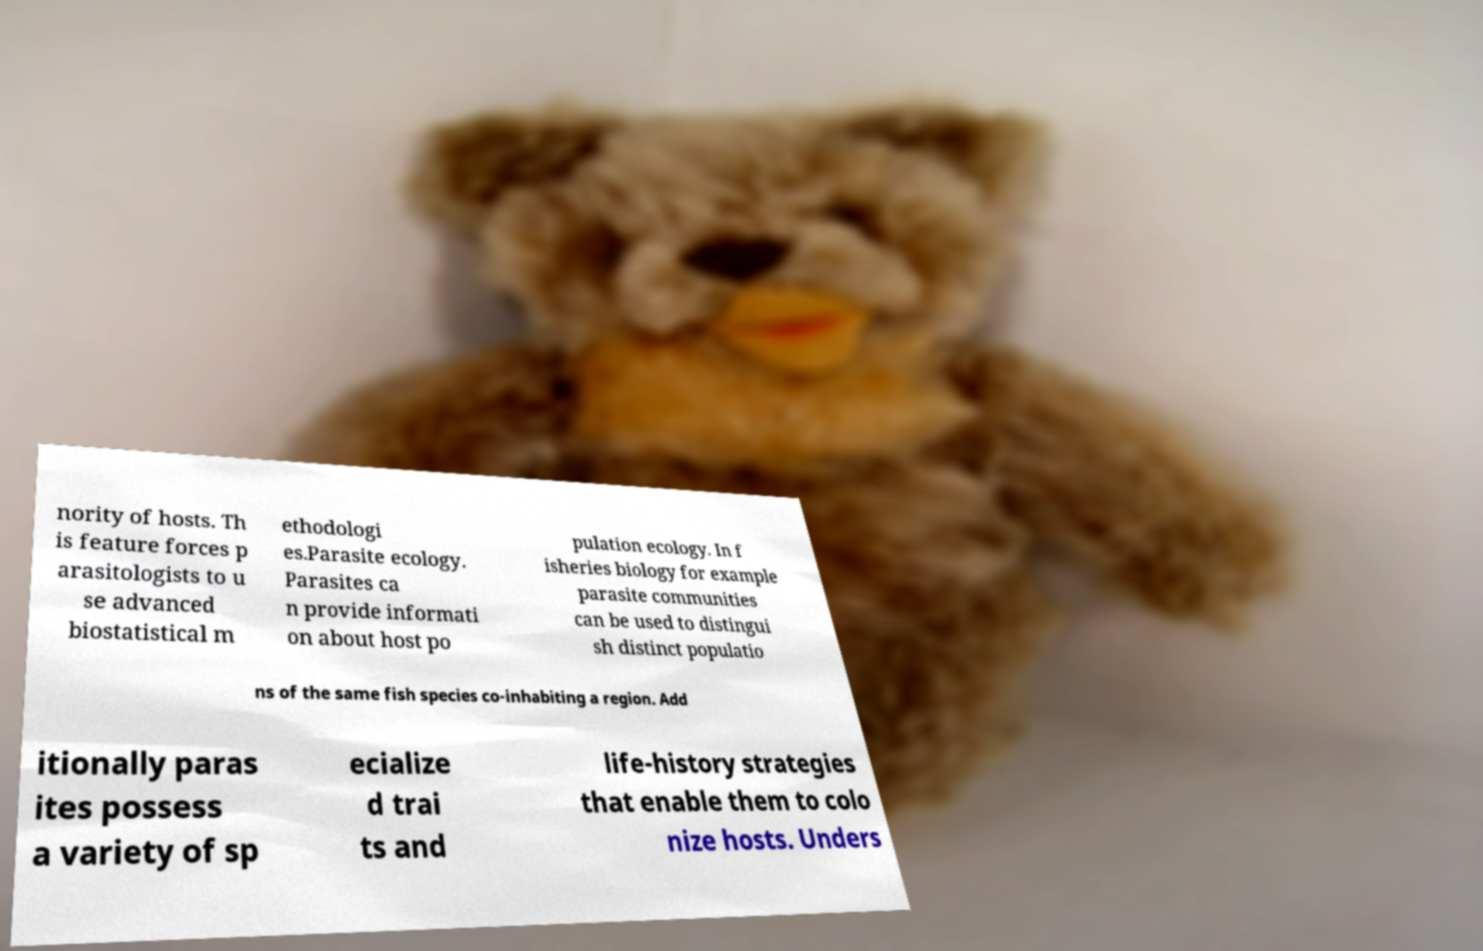Could you assist in decoding the text presented in this image and type it out clearly? nority of hosts. Th is feature forces p arasitologists to u se advanced biostatistical m ethodologi es.Parasite ecology. Parasites ca n provide informati on about host po pulation ecology. In f isheries biology for example parasite communities can be used to distingui sh distinct populatio ns of the same fish species co-inhabiting a region. Add itionally paras ites possess a variety of sp ecialize d trai ts and life-history strategies that enable them to colo nize hosts. Unders 